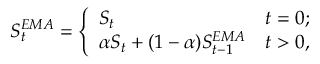Convert formula to latex. <formula><loc_0><loc_0><loc_500><loc_500>S _ { t } ^ { E M A } = \left \{ \begin{array} { l l } { S _ { t } } & { t = 0 ; } \\ { \alpha S _ { t } + ( 1 - \alpha ) S _ { t - 1 } ^ { E M A } } & { t > 0 , } \end{array}</formula> 